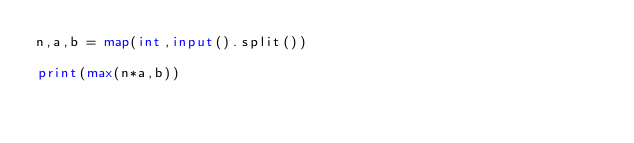Convert code to text. <code><loc_0><loc_0><loc_500><loc_500><_Python_>n,a,b = map(int,input().split())

print(max(n*a,b))</code> 